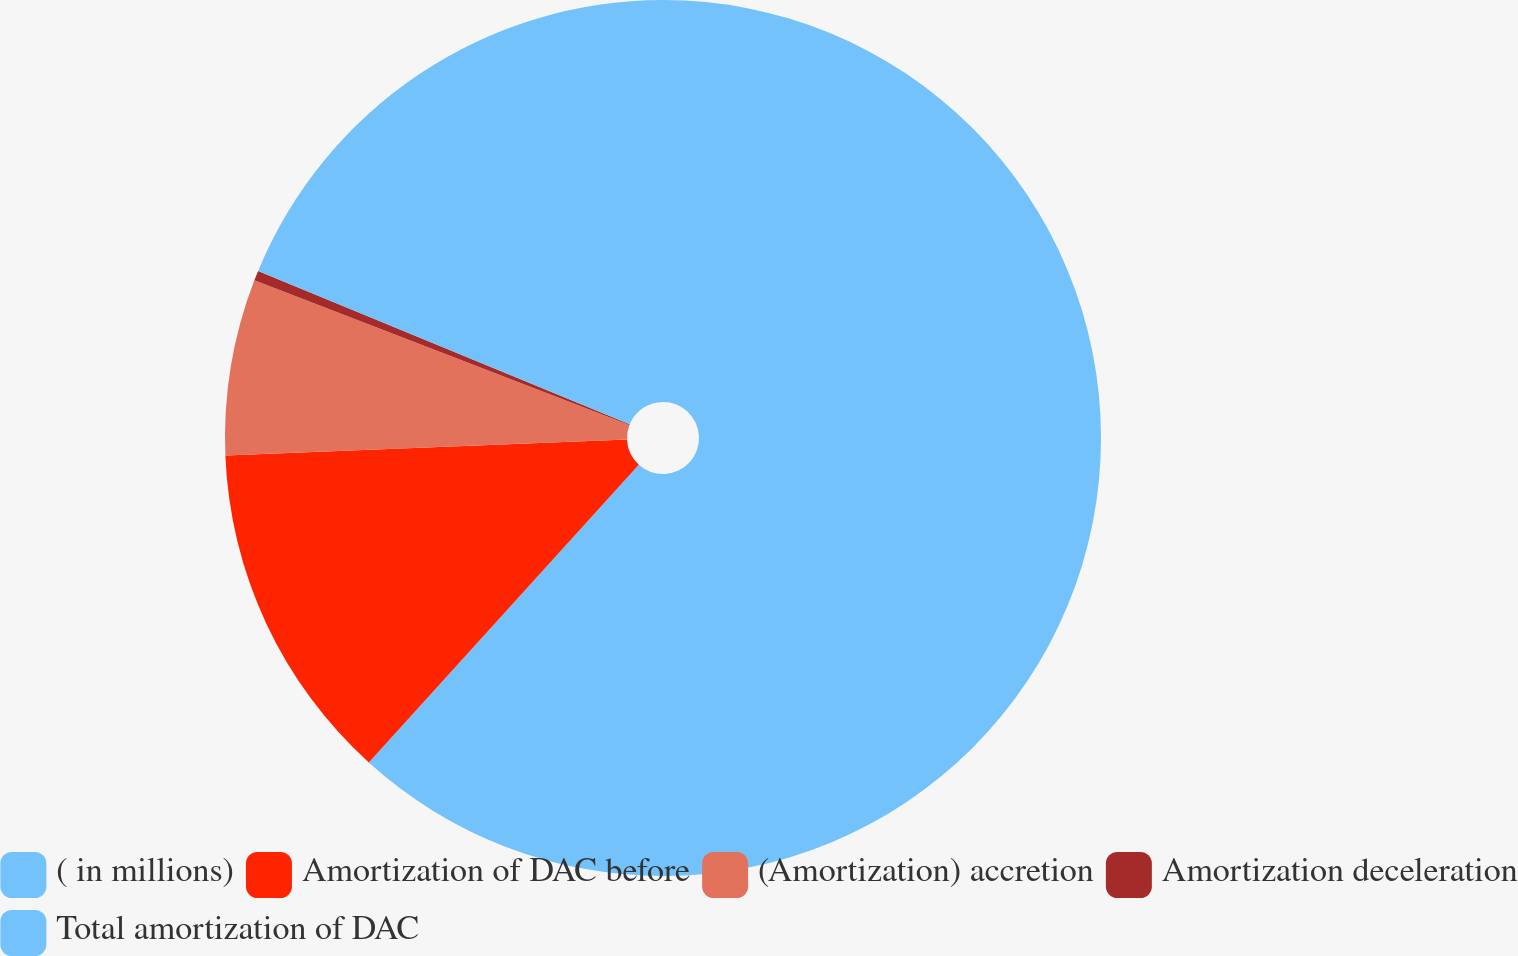<chart> <loc_0><loc_0><loc_500><loc_500><pie_chart><fcel>( in millions)<fcel>Amortization of DAC before<fcel>(Amortization) accretion<fcel>Amortization deceleration<fcel>Total amortization of DAC<nl><fcel>61.72%<fcel>12.64%<fcel>6.5%<fcel>0.37%<fcel>18.77%<nl></chart> 